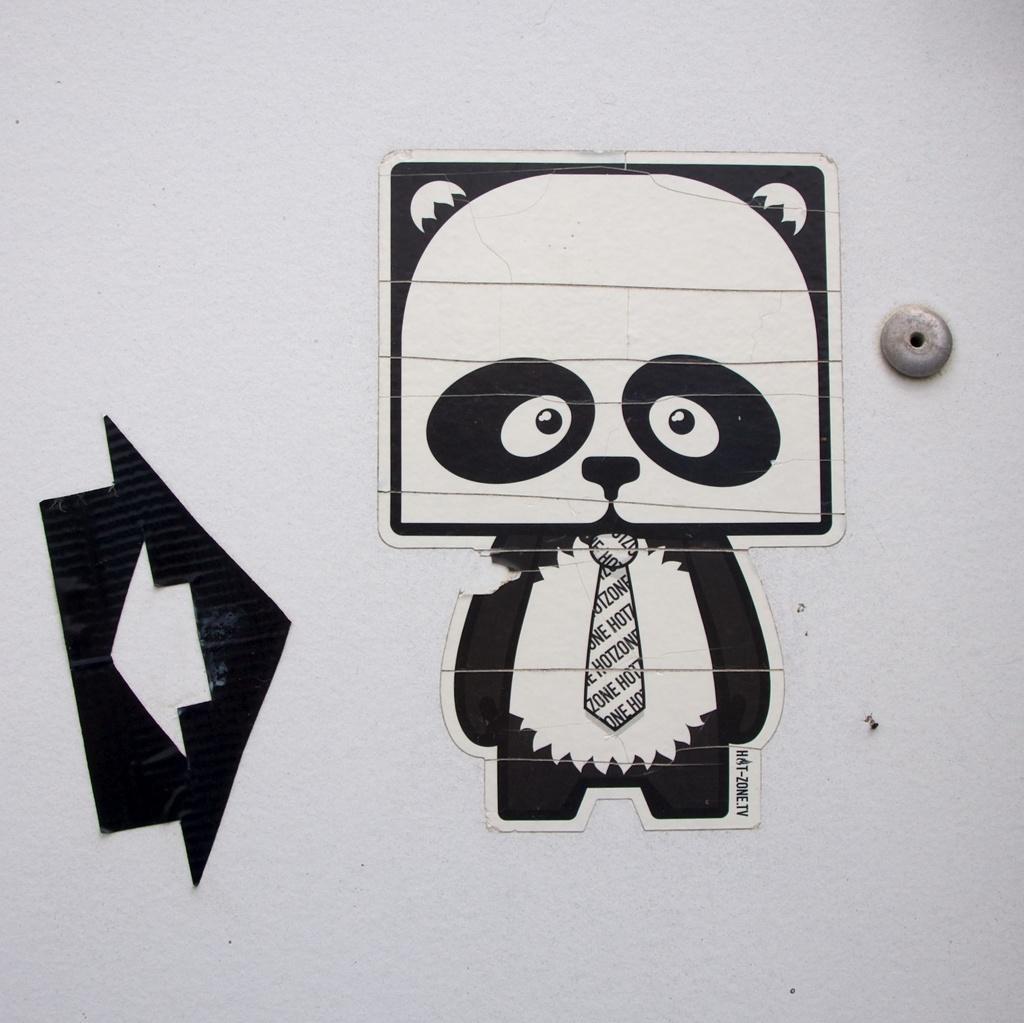Could you give a brief overview of what you see in this image? In this image there is the wall, there are objects on the wall. 